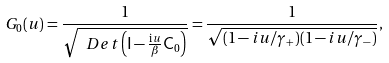<formula> <loc_0><loc_0><loc_500><loc_500>G _ { 0 } ( u ) = \frac { 1 } { \sqrt { \ D e t \left ( \mathsf I - \frac { \mathrm i u } { \beta } \mathsf C _ { 0 } \right ) } } = \frac { 1 } { \sqrt { ( 1 - i u / \gamma _ { + } ) ( 1 - i u / \gamma _ { - } ) } } ,</formula> 